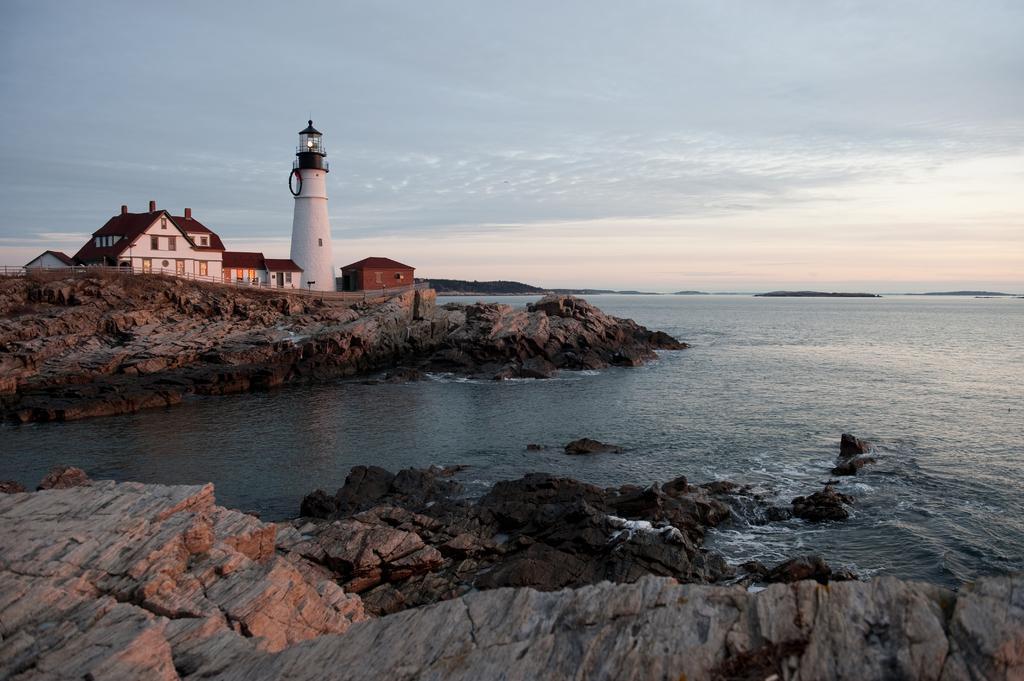How would you summarize this image in a sentence or two? There is water. Also there are rocks. In the back there are buildings and a lighthouse. In the background there is sky. 